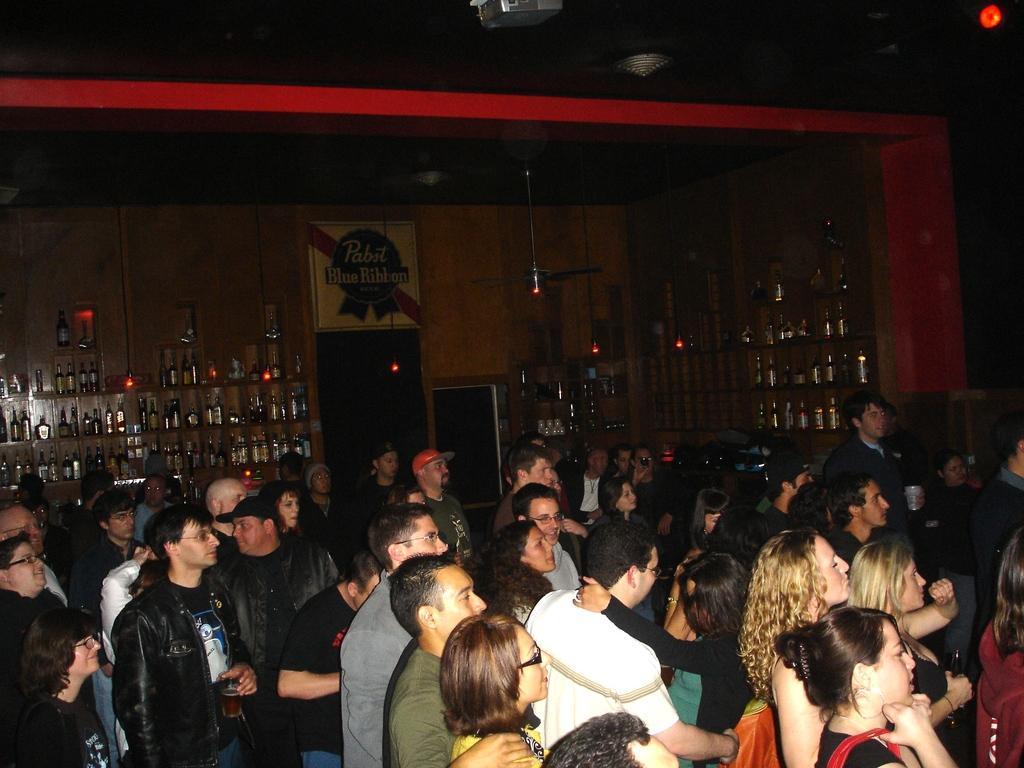Could you give a brief overview of what you see in this image? In this image we can see a group of persons. Behind the persons we can see a wall and a group of bottles on the racks. On the wall we can see the text. At the top we can see the roof. 